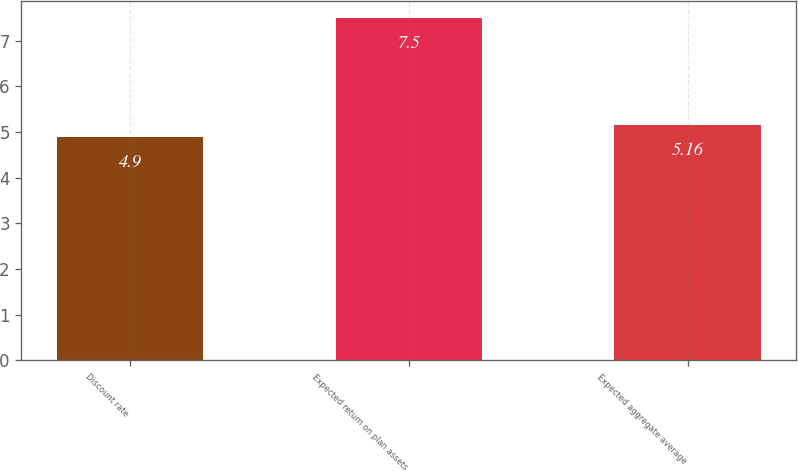Convert chart to OTSL. <chart><loc_0><loc_0><loc_500><loc_500><bar_chart><fcel>Discount rate<fcel>Expected return on plan assets<fcel>Expected aggregate average<nl><fcel>4.9<fcel>7.5<fcel>5.16<nl></chart> 